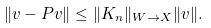Convert formula to latex. <formula><loc_0><loc_0><loc_500><loc_500>\| v - P v \| \leq \| K _ { n } \| _ { W \to X } \| v \| .</formula> 